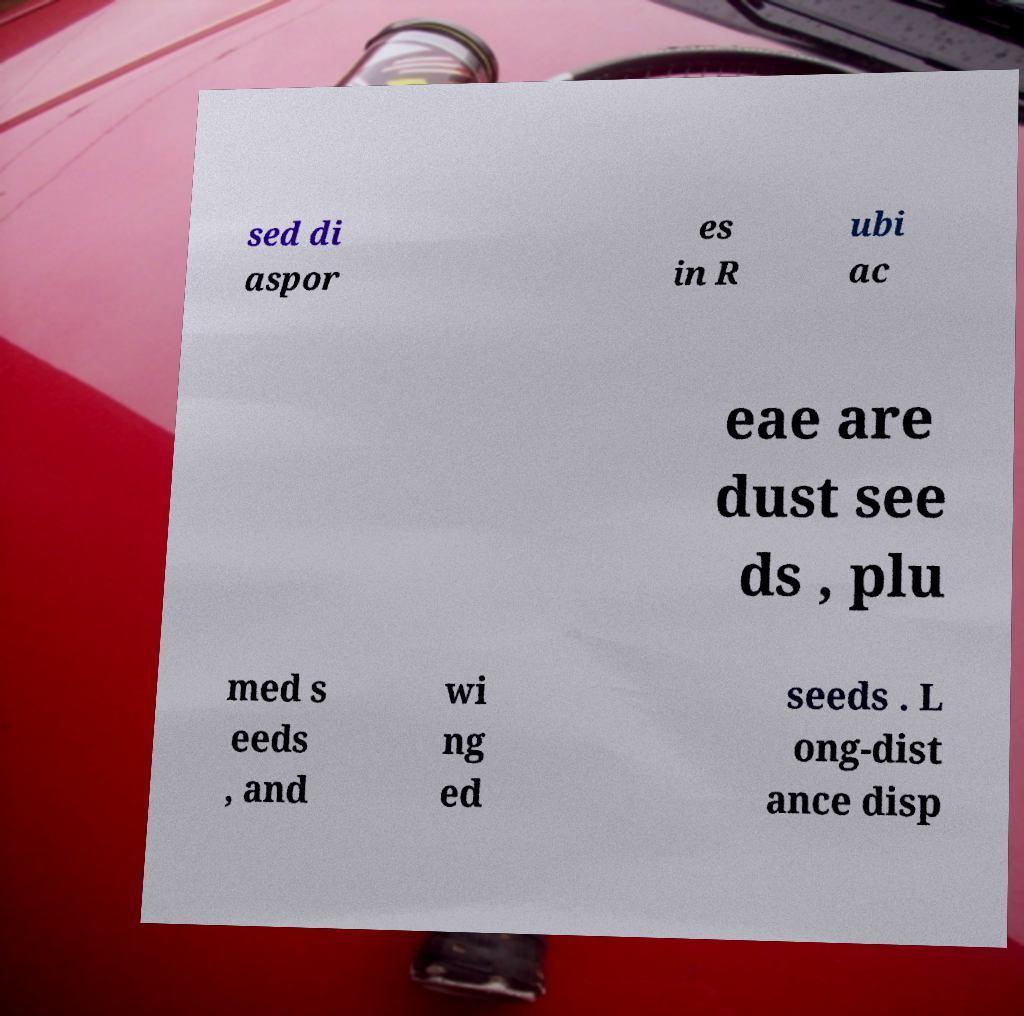There's text embedded in this image that I need extracted. Can you transcribe it verbatim? sed di aspor es in R ubi ac eae are dust see ds , plu med s eeds , and wi ng ed seeds . L ong-dist ance disp 